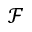<formula> <loc_0><loc_0><loc_500><loc_500>\mathcal { F }</formula> 